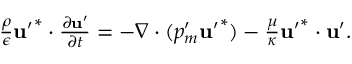<formula> <loc_0><loc_0><loc_500><loc_500>\begin{array} { r } { \frac { \rho } { \epsilon } u ^ { \prime } ^ { * } \cdot \frac { \partial u ^ { \prime } } { \partial t } = - \nabla \cdot ( p _ { m } ^ { \prime } u ^ { \prime } ^ { * } ) - \frac { \mu } { \kappa } u ^ { \prime } ^ { * } \cdot u ^ { \prime } . } \end{array}</formula> 